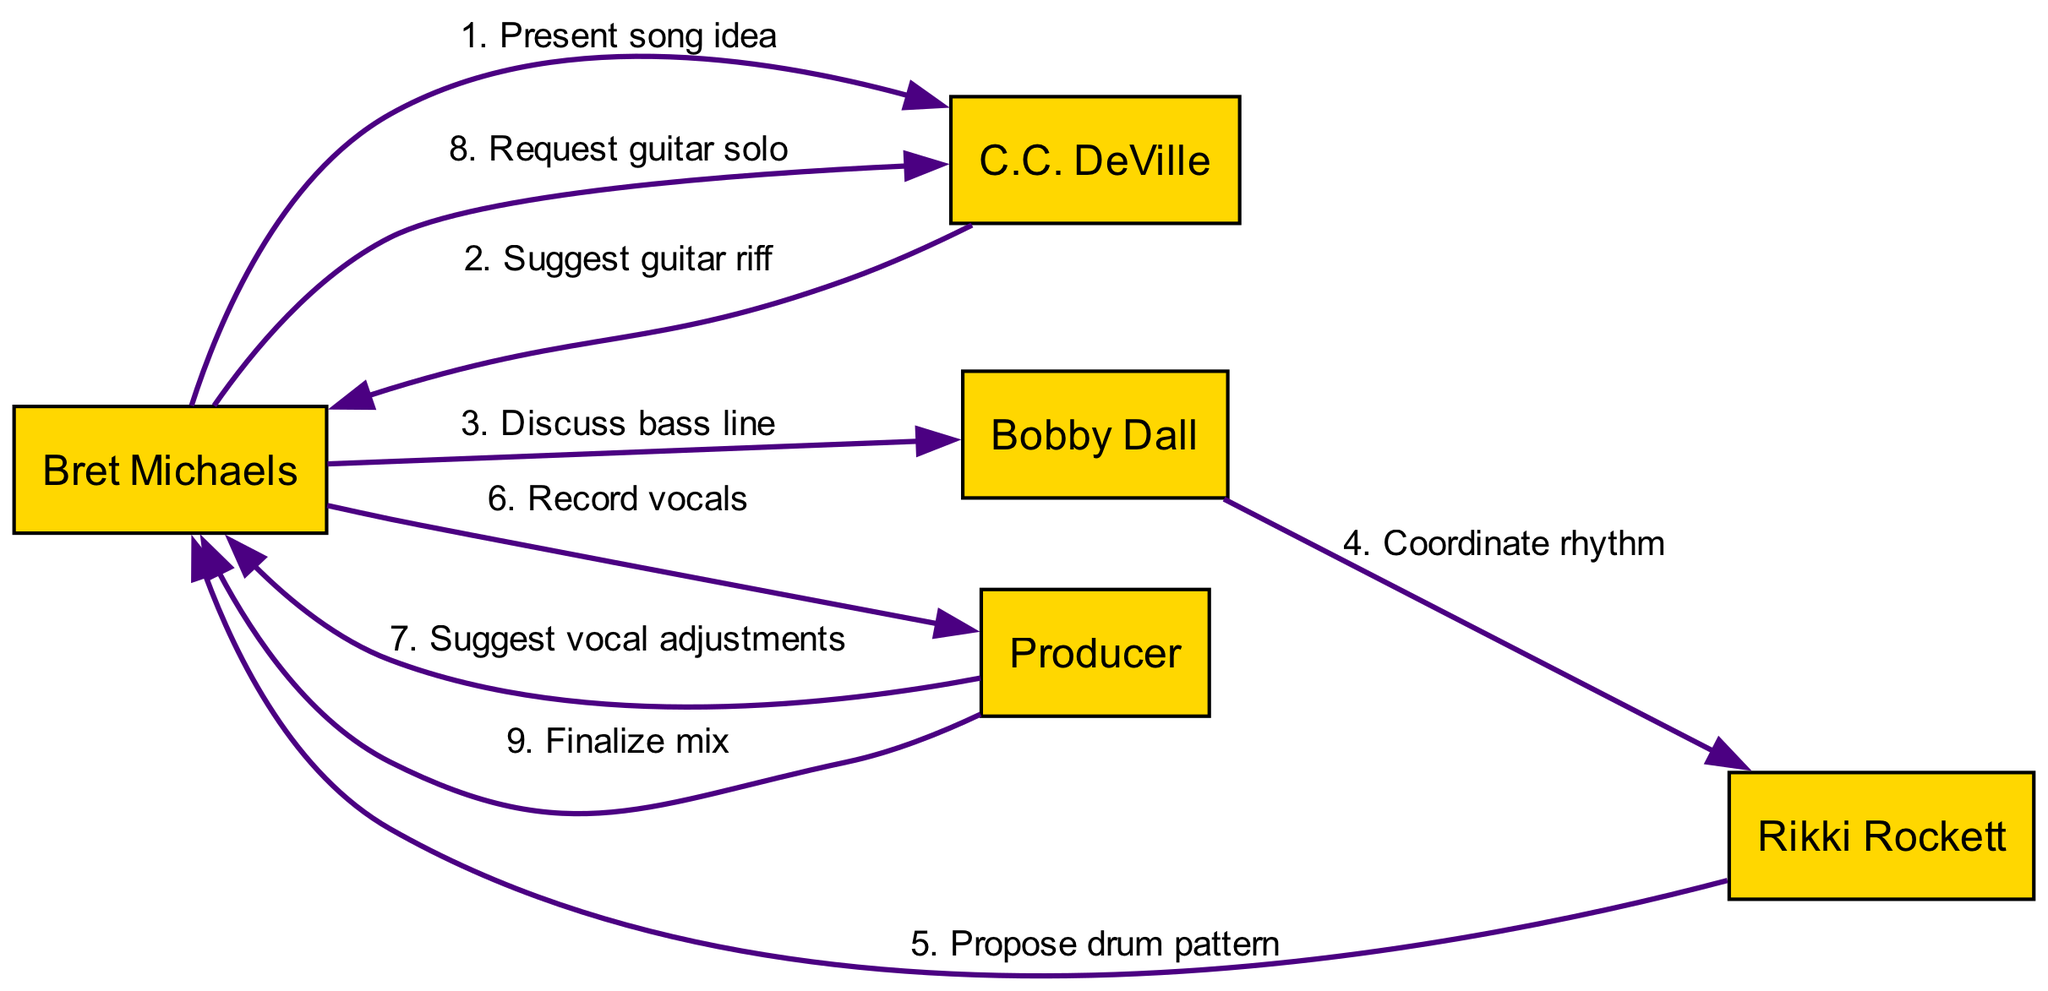What is the first interaction in the recording session? The first interaction in the diagram is when Bret Michaels presents the song idea to C.C. DeVille. This is indicated by the first arrow connecting Bret Michaels to C.C. DeVille with the message specified.
Answer: Present song idea How many actors are involved in the recording session? The diagram lists five actors: Bret Michaels, C.C. DeVille, Bobby Dall, Rikki Rockett, and Producer. Counting each node in the diagram shows there are five distinct actors interacting.
Answer: 5 Who suggests the guitar riff? C.C. DeVille suggests the guitar riff to Bret Michaels. This is shown by the directed edge from C.C. DeVille to Bret Michaels with the corresponding message.
Answer: C.C. DeVille Which actor coordinates the rhythm? Bobby Dall coordinates the rhythm with Rikki Rockett, as indicated by the directed edge from Bobby Dall to Rikki Rockett that specifies this action.
Answer: Bobby Dall How many interactions are there in total? There are eight interactions in the diagram, as counted from the list of edges connecting the actors while each edge represents a unique interaction conveyed in the messages.
Answer: 8 What interaction occurs just before the Producer suggests vocal adjustments? The interaction just before the Producer suggests vocal adjustments is where Bret Michaels records vocals. This is represented by the directed edge leading from Bret Michaels to the Producer.
Answer: Record vocals Which actor does Bret Michaels request a guitar solo from? Bret Michaels requests a guitar solo from C.C. DeVille, which is indicated by the directed edge from Bret Michaels to C.C. DeVille with that specific message.
Answer: C.C. DeVille What is the last action taken in the diagram? The last action in the diagram is the Producer finalizing the mix, which is shown as the last directed edge leading from the Producer to Bret Michaels, indicating the conclusion of the recording session.
Answer: Finalize mix 